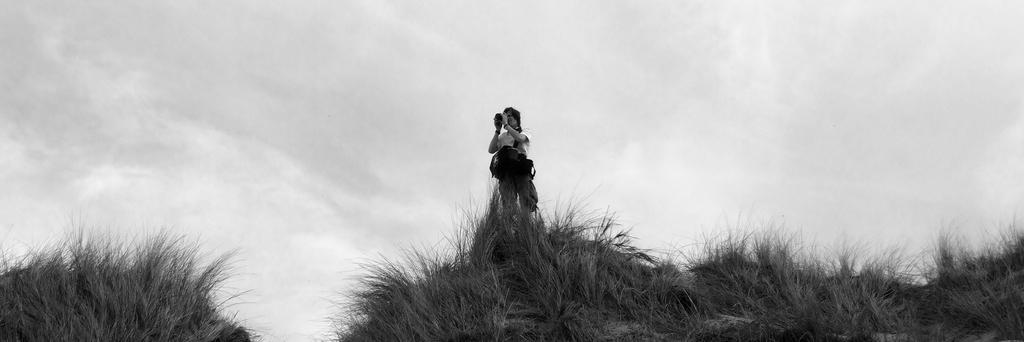What is the main subject of the image? There is a person standing in the image. Where is the person standing? The person is standing on a hill. What is the surface of the hill covered with? The hill surface is covered with dried grass. What can be seen in the sky in the image? The sky is visible in the image, and there are clouds in the sky. Reasoning: Let' Let's think step by step in order to produce the conversation. We start by identifying the main subject of the image, which is the person standing. Then, we describe the location of the person, which is on a hill. Next, we mention the surface of the hill, which is covered with dried grass. Finally, we describe the sky and its condition, which is visible with clouds present. Absurd Question/Answer: What type of pie is being served at the news conference in the image? There is no news conference or pie present in the image; it features a person standing on a hill with a grassy surface and clouds in the sky. 